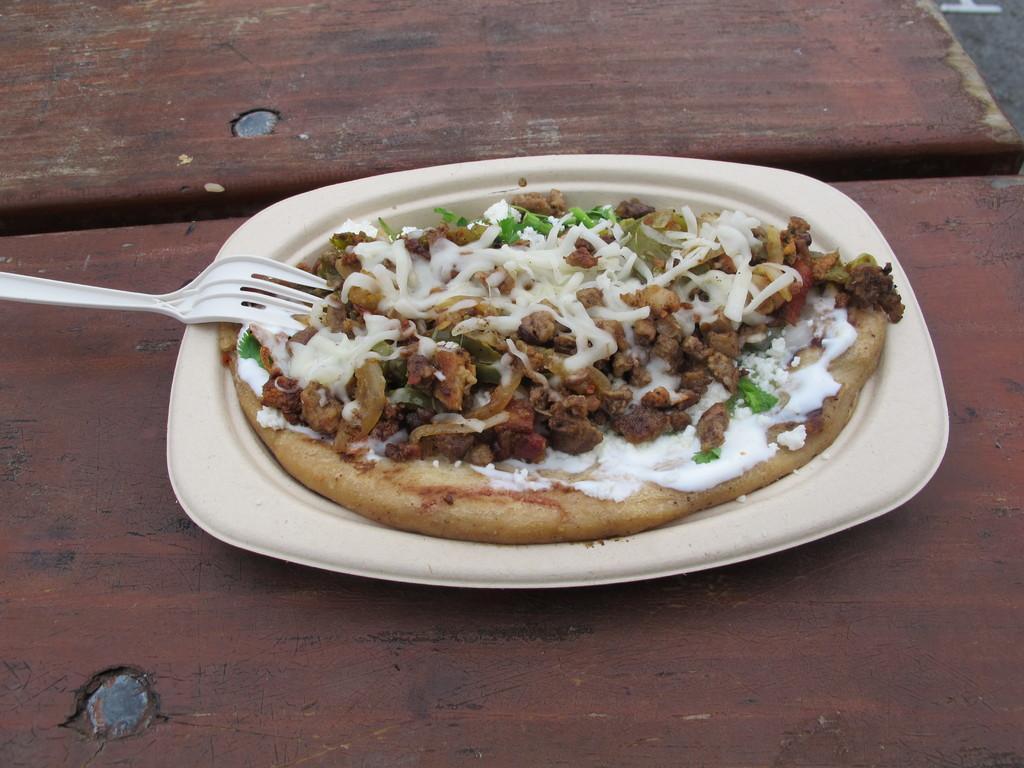In one or two sentences, can you explain what this image depicts? In this picture we can see a pizza and a fork in the plate. 